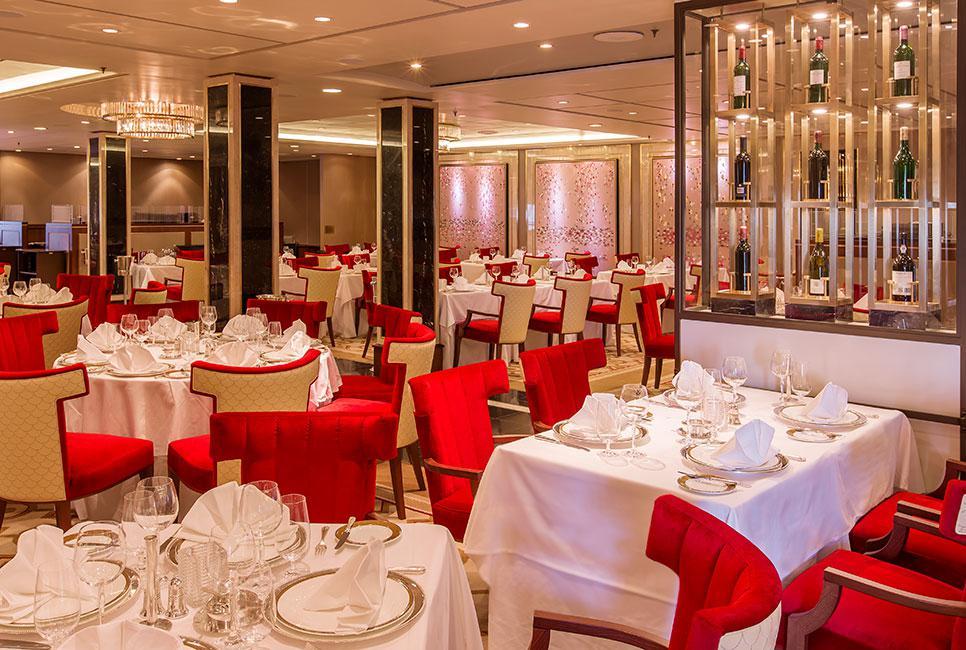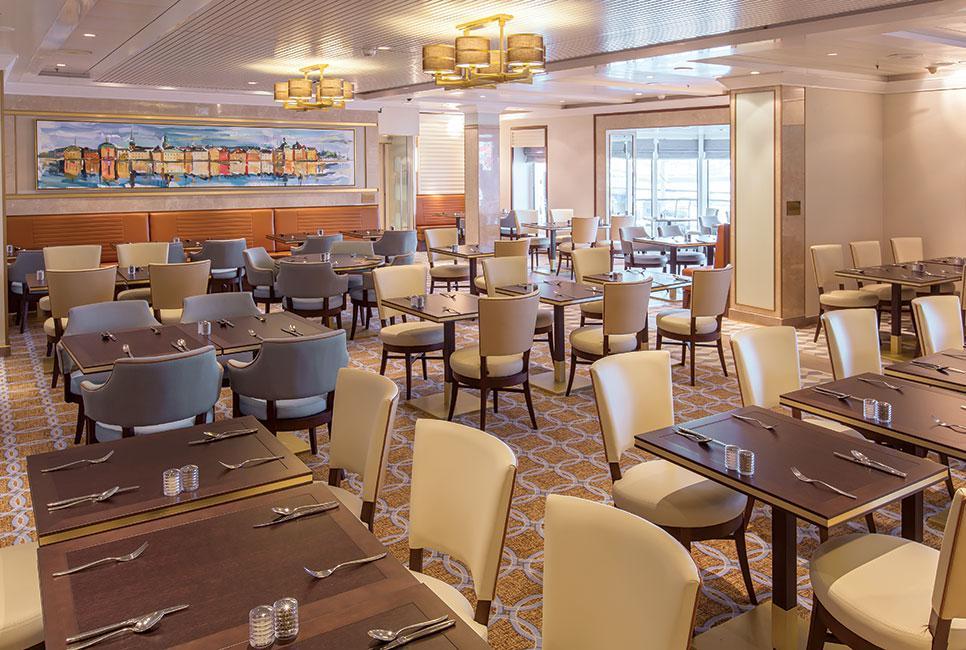The first image is the image on the left, the second image is the image on the right. Given the left and right images, does the statement "One of the images has chairs with red upholstery and white backs." hold true? Answer yes or no. Yes. 